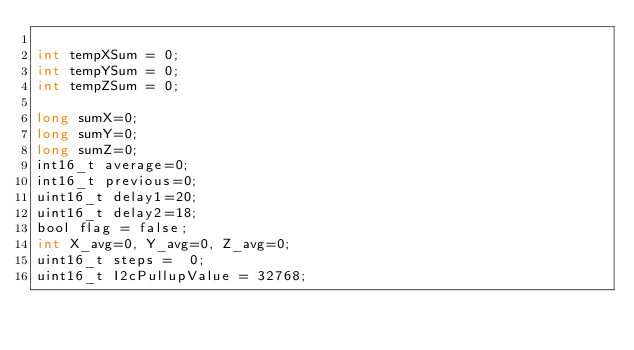<code> <loc_0><loc_0><loc_500><loc_500><_C_>
int tempXSum = 0;
int tempYSum = 0;
int tempZSum = 0;

long sumX=0;
long sumY=0;
long sumZ=0;
int16_t average=0;
int16_t previous=0;
uint16_t delay1=20;
uint16_t delay2=18; 
bool flag = false;
int X_avg=0, Y_avg=0, Z_avg=0;
uint16_t steps =  0;
uint16_t I2cPullupValue = 32768;</code> 